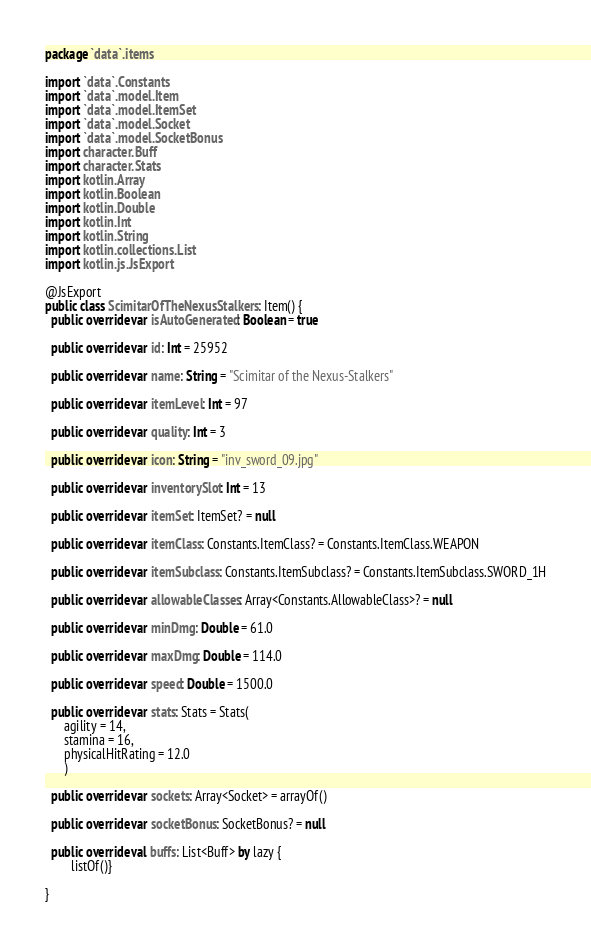Convert code to text. <code><loc_0><loc_0><loc_500><loc_500><_Kotlin_>package `data`.items

import `data`.Constants
import `data`.model.Item
import `data`.model.ItemSet
import `data`.model.Socket
import `data`.model.SocketBonus
import character.Buff
import character.Stats
import kotlin.Array
import kotlin.Boolean
import kotlin.Double
import kotlin.Int
import kotlin.String
import kotlin.collections.List
import kotlin.js.JsExport

@JsExport
public class ScimitarOfTheNexusStalkers : Item() {
  public override var isAutoGenerated: Boolean = true

  public override var id: Int = 25952

  public override var name: String = "Scimitar of the Nexus-Stalkers"

  public override var itemLevel: Int = 97

  public override var quality: Int = 3

  public override var icon: String = "inv_sword_09.jpg"

  public override var inventorySlot: Int = 13

  public override var itemSet: ItemSet? = null

  public override var itemClass: Constants.ItemClass? = Constants.ItemClass.WEAPON

  public override var itemSubclass: Constants.ItemSubclass? = Constants.ItemSubclass.SWORD_1H

  public override var allowableClasses: Array<Constants.AllowableClass>? = null

  public override var minDmg: Double = 61.0

  public override var maxDmg: Double = 114.0

  public override var speed: Double = 1500.0

  public override var stats: Stats = Stats(
      agility = 14,
      stamina = 16,
      physicalHitRating = 12.0
      )

  public override var sockets: Array<Socket> = arrayOf()

  public override var socketBonus: SocketBonus? = null

  public override val buffs: List<Buff> by lazy {
        listOf()}

}
</code> 